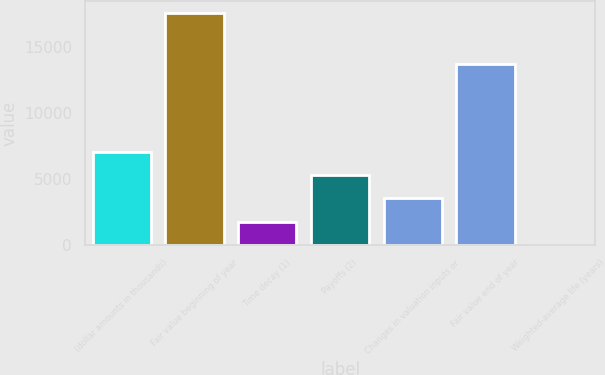Convert chart to OTSL. <chart><loc_0><loc_0><loc_500><loc_500><bar_chart><fcel>(dollar amounts in thousands)<fcel>Fair value beginning of year<fcel>Time decay (1)<fcel>Payoffs (2)<fcel>Changes in valuation inputs or<fcel>Fair value end of year<fcel>Weighted-average life (years)<nl><fcel>7037.42<fcel>17585<fcel>1763.63<fcel>5279.49<fcel>3521.56<fcel>13747<fcel>5.7<nl></chart> 